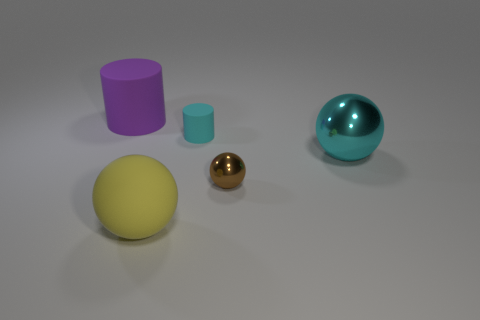What textures and material properties can be observed among the objects in the image? The image showcases a variety of textures and material properties. The yellow sphere and gold sphere seem to have smoother surfaces with shiny, reflective qualities, suggesting they might be made of polished material like plastic or even metal for the gold one. The purple and cyan cylinders exhibit a matte finish with no reflections, indicating a likely dull or non-metallic surface, and the cyan sphere has a translucent appearance, hinting at a material like glass or perhaps a shiny plastic. 